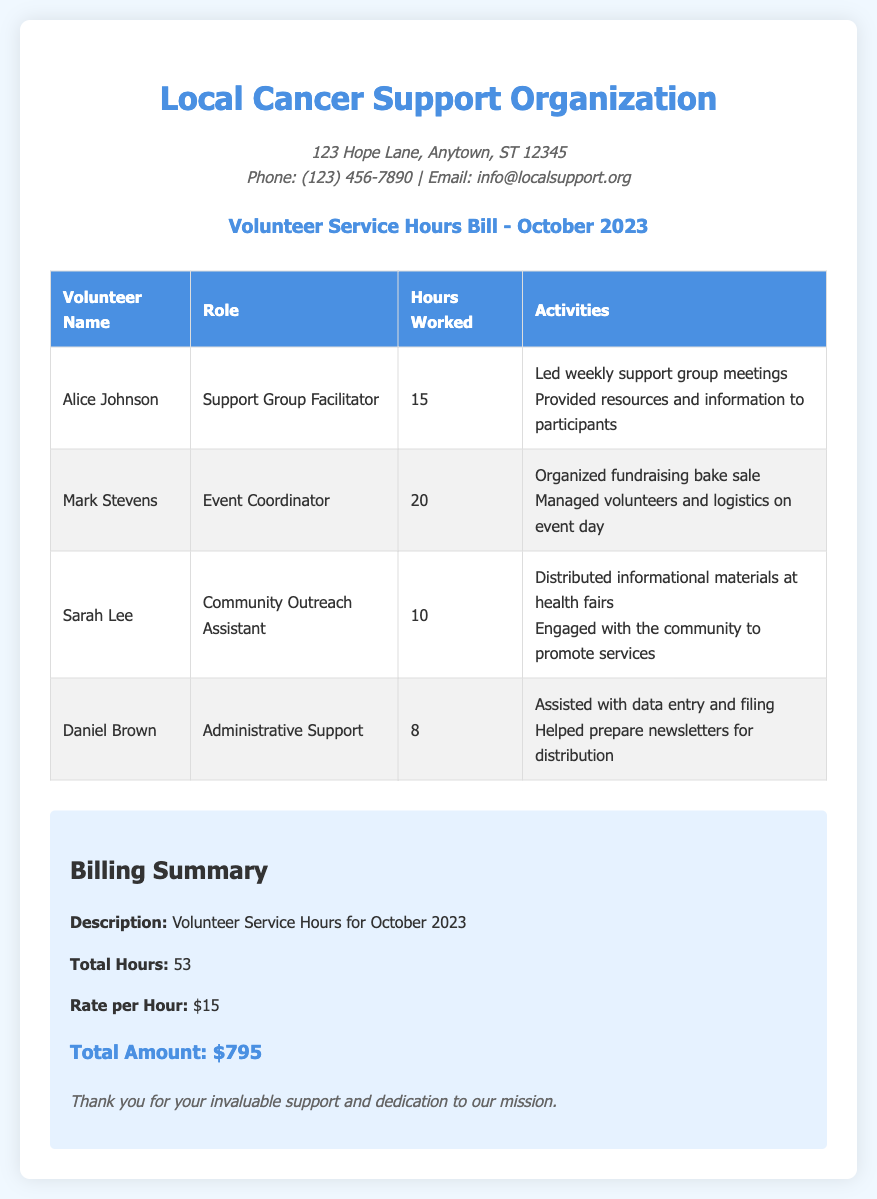What is the total number of volunteer hours? The total number of volunteer hours is calculated from the individual hours worked by each volunteer, which adds up to 53.
Answer: 53 Who is the Event Coordinator? The Event Coordinator's name is listed in the table, which shows Mark Stevens as the volunteer fulfilling this role.
Answer: Mark Stevens How many hours did Sarah Lee work? The number of hours worked by Sarah Lee can be found in the table, which indicates she worked for 10 hours.
Answer: 10 What activities did Alice Johnson lead? The activities led by Alice Johnson are specified in the document, which mentions she led weekly support group meetings and provided resources.
Answer: Led weekly support group meetings What is the rate per hour for volunteer work? The rate per hour for volunteer work is stated in the billing summary, which indicates a rate of $15.
Answer: $15 What is the total amount billed for the volunteer hours? The total amount billed is calculated based on the total hours and the rate per hour, resulting in $795.
Answer: $795 Who assisted with data entry and filing? The volunteer who assisted with data entry and filing is identified as Daniel Brown in the document.
Answer: Daniel Brown What is the role of Sarah Lee? Sarah Lee's role is detailed in the table, where she is noted as the Community Outreach Assistant.
Answer: Community Outreach Assistant 